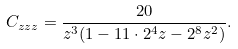Convert formula to latex. <formula><loc_0><loc_0><loc_500><loc_500>C _ { z z z } = \frac { 2 0 } { z ^ { 3 } ( 1 - 1 1 \cdot 2 ^ { 4 } z - 2 ^ { 8 } z ^ { 2 } ) } .</formula> 